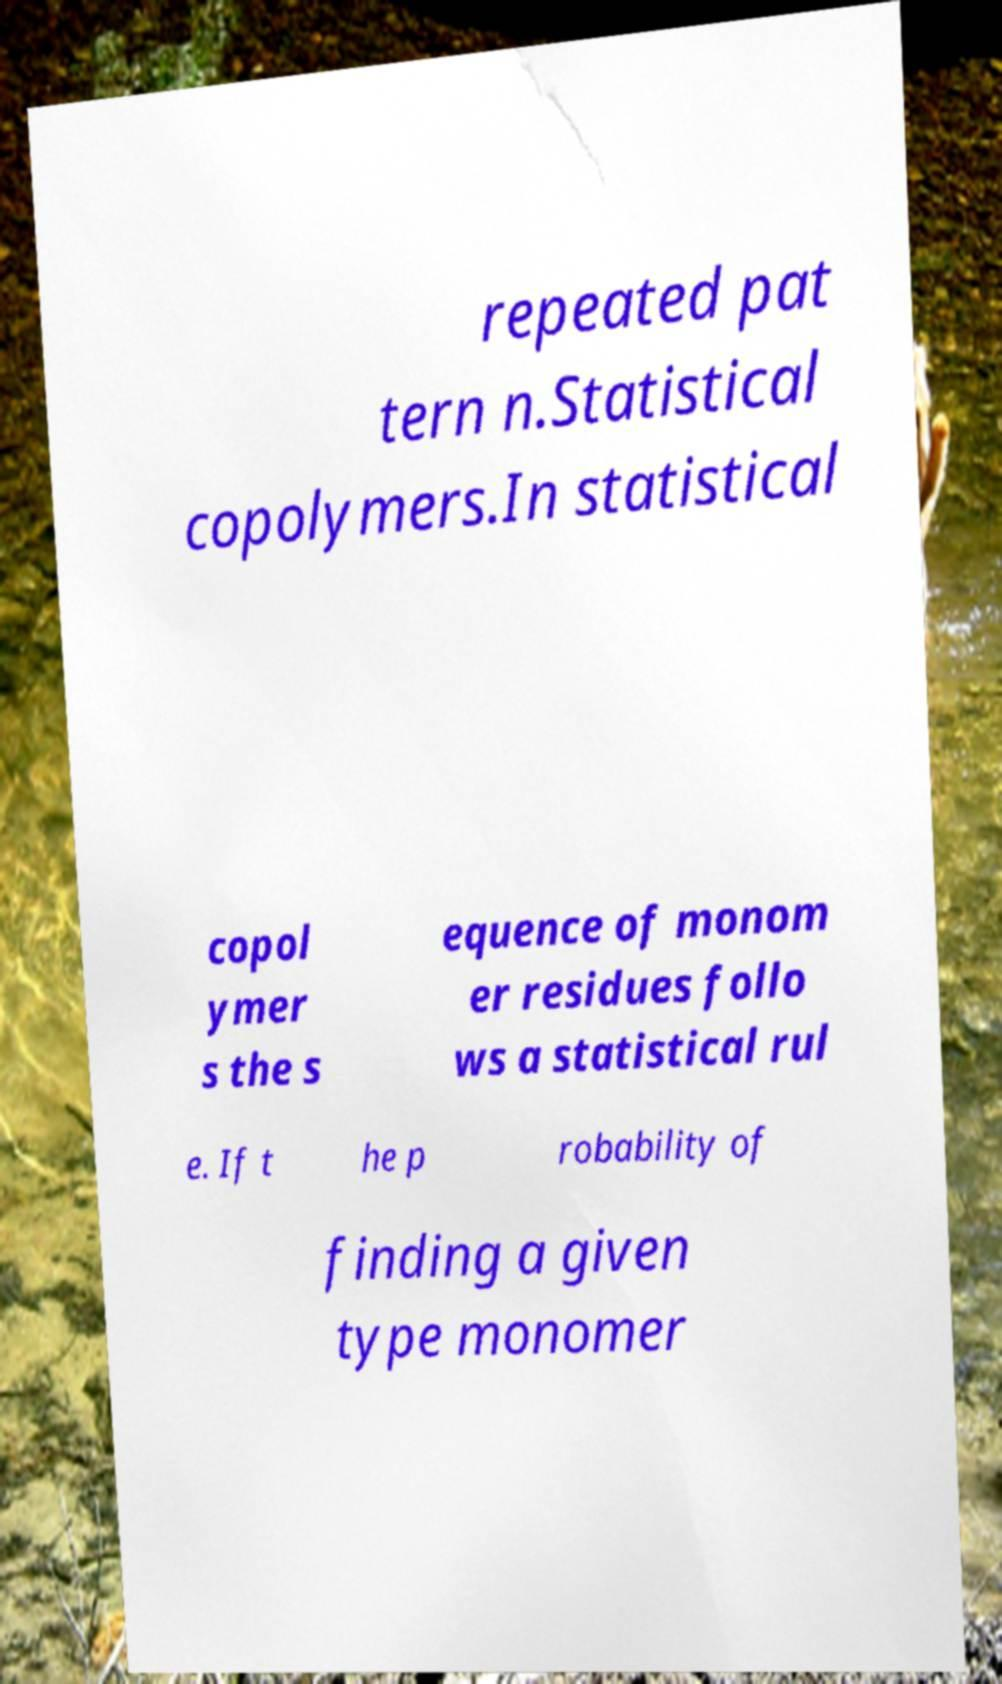Can you accurately transcribe the text from the provided image for me? repeated pat tern n.Statistical copolymers.In statistical copol ymer s the s equence of monom er residues follo ws a statistical rul e. If t he p robability of finding a given type monomer 